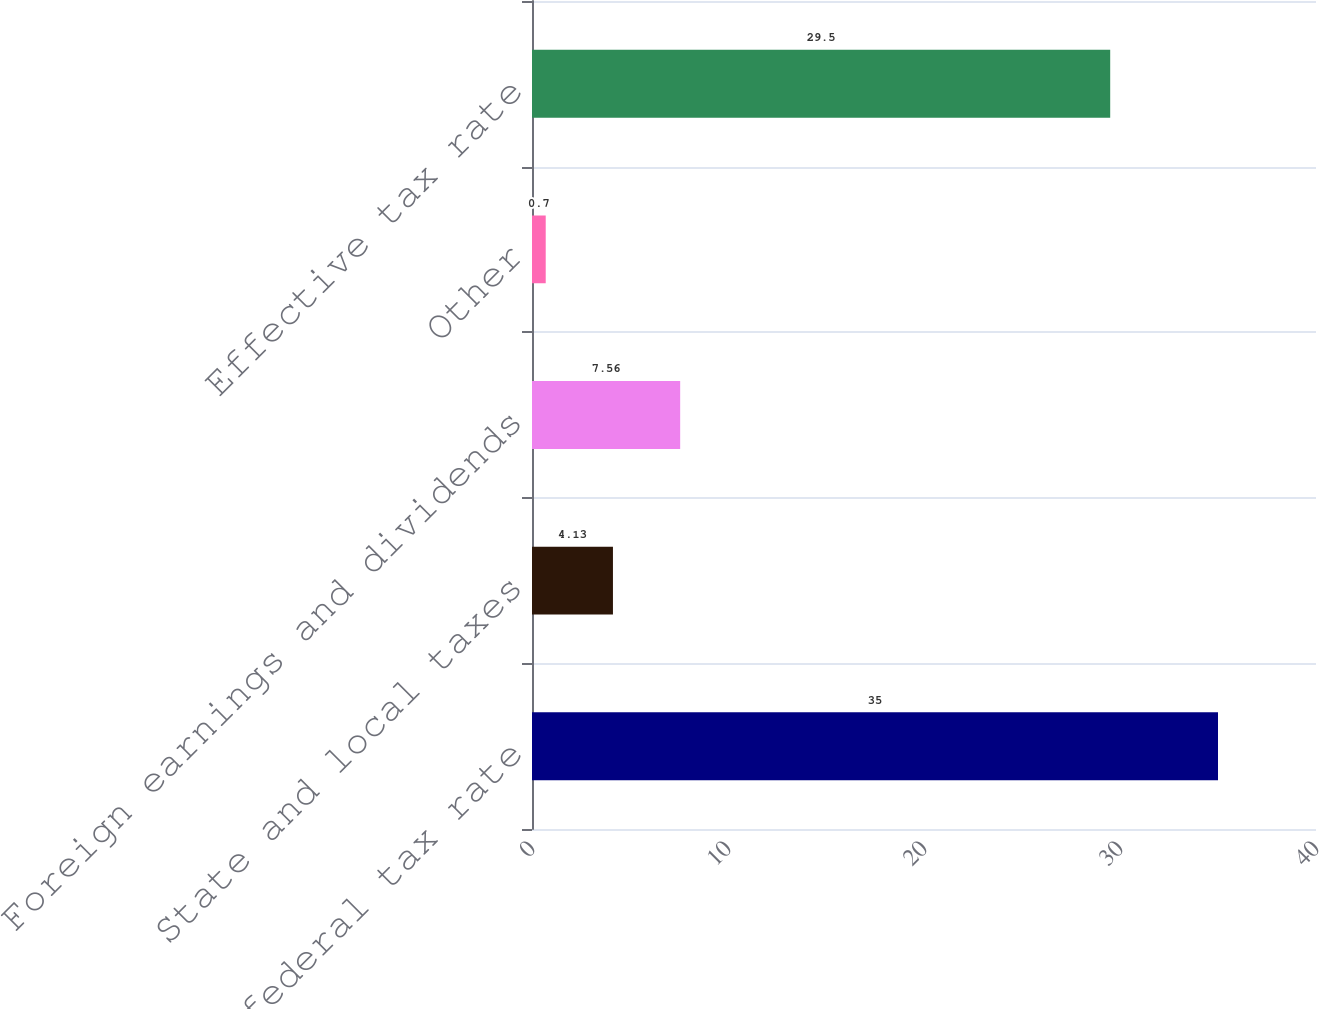<chart> <loc_0><loc_0><loc_500><loc_500><bar_chart><fcel>US statutory federal tax rate<fcel>State and local taxes<fcel>Foreign earnings and dividends<fcel>Other<fcel>Effective tax rate<nl><fcel>35<fcel>4.13<fcel>7.56<fcel>0.7<fcel>29.5<nl></chart> 